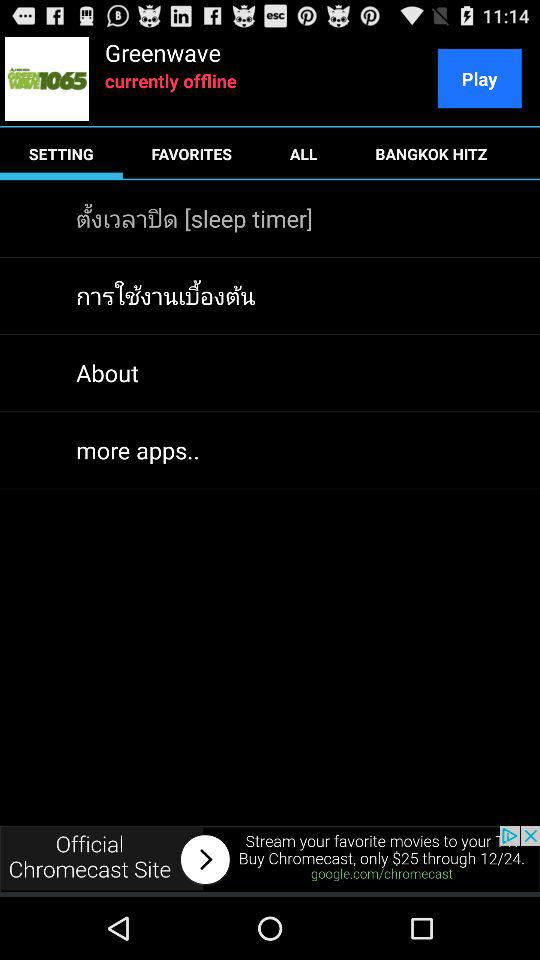What is the application name? The application name is "Greenwave". 